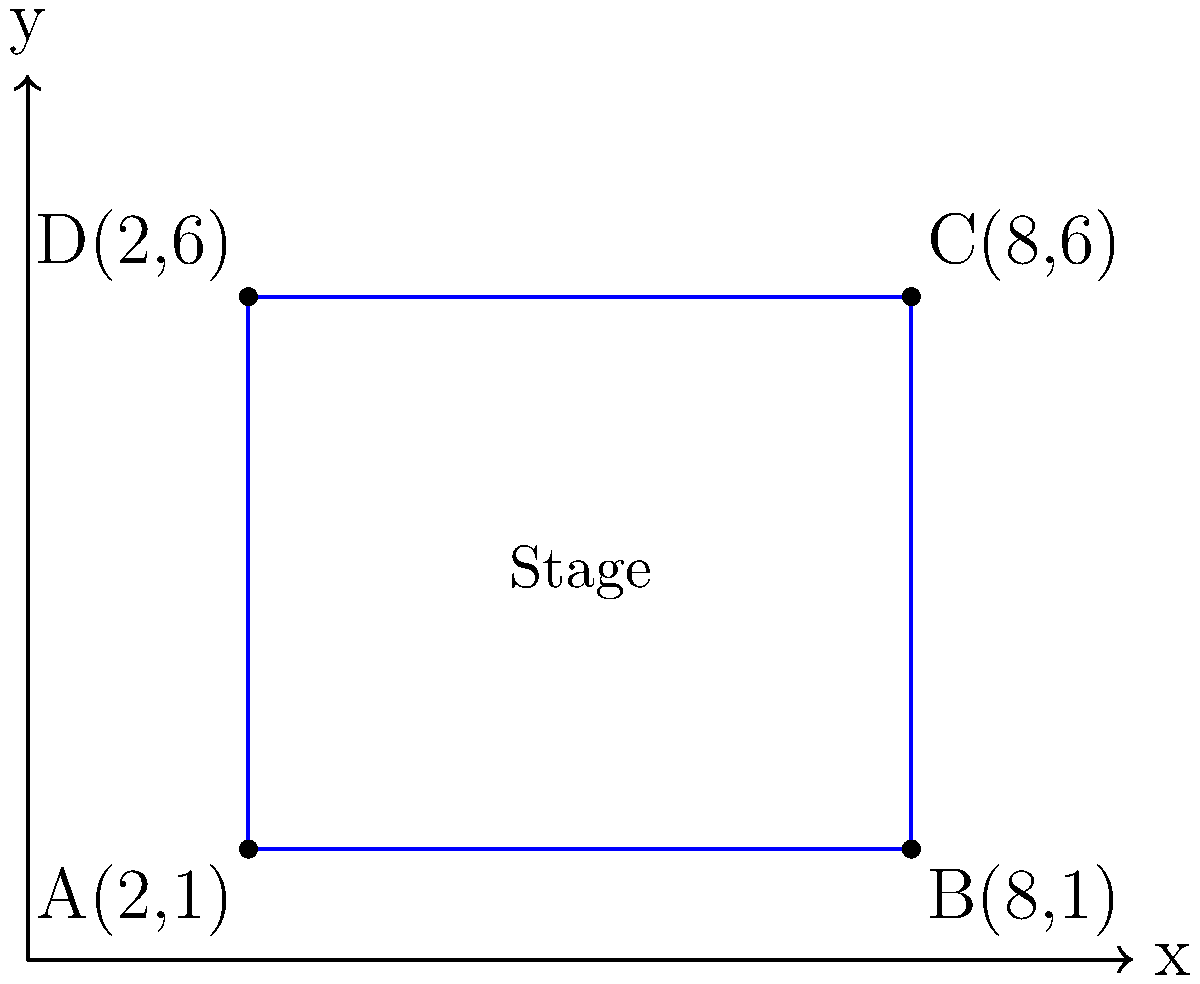As the star of a new salsa-themed telenovela, you're preparing for a grand performance on a rectangular stage. The stage's corners are represented by points A(2,1), B(8,1), C(8,6), and D(2,6) on a coordinate plane, where each unit represents 1 meter. Calculate the area of the stage in square meters to ensure there's enough space for your passionate salsa moves. Let's approach this step-by-step:

1) The stage forms a rectangle in the coordinate plane.

2) To find the area, we need the length and width of the rectangle.

3) Length (along x-axis):
   $x$-coordinate of B - $x$-coordinate of A
   $= 8 - 2 = 6$ meters

4) Width (along y-axis):
   $y$-coordinate of D - $y$-coordinate of A
   $= 6 - 1 = 5$ meters

5) Area of a rectangle is given by the formula:
   $A = length \times width$

6) Substituting our values:
   $A = 6 \times 5 = 30$ square meters

Therefore, the area of the stage is 30 square meters.
Answer: 30 m² 